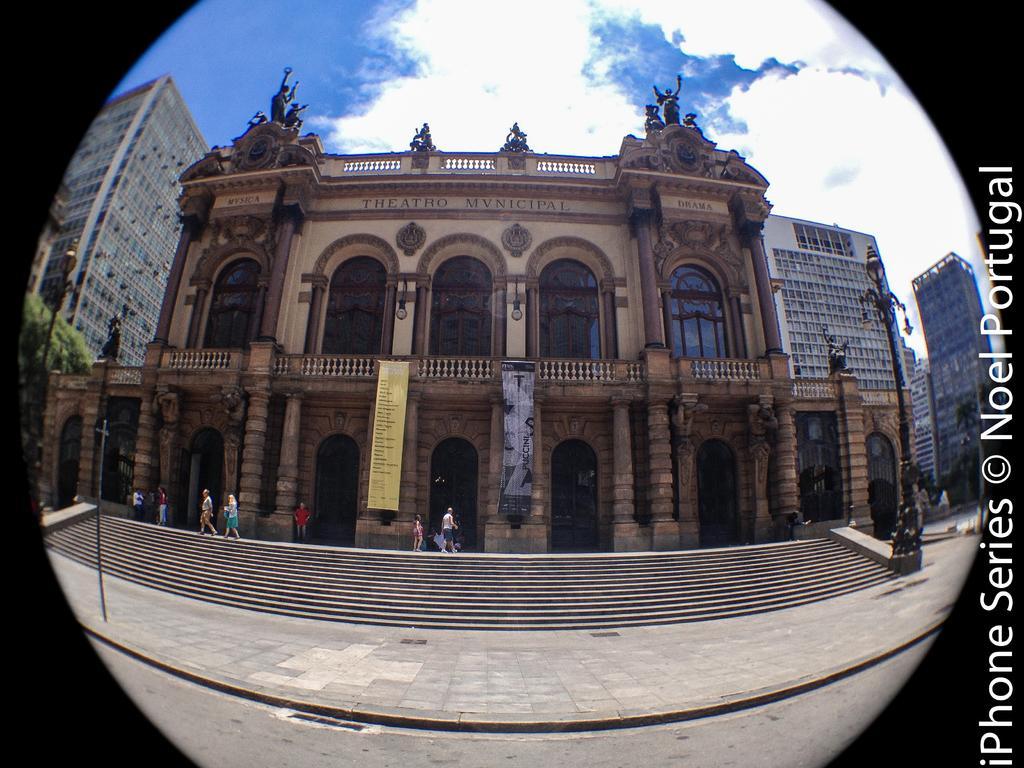Describe this image in one or two sentences. In this image, we can see a few buildings, trees, poles, with lights, glass windows, pillars, railings, banners. At the bottom, we can see few stairs, footpath and road. In the middle of the image, we can see few people. Top of the image, there is a cloudy sky. On the right side of the image, we can see some text. 